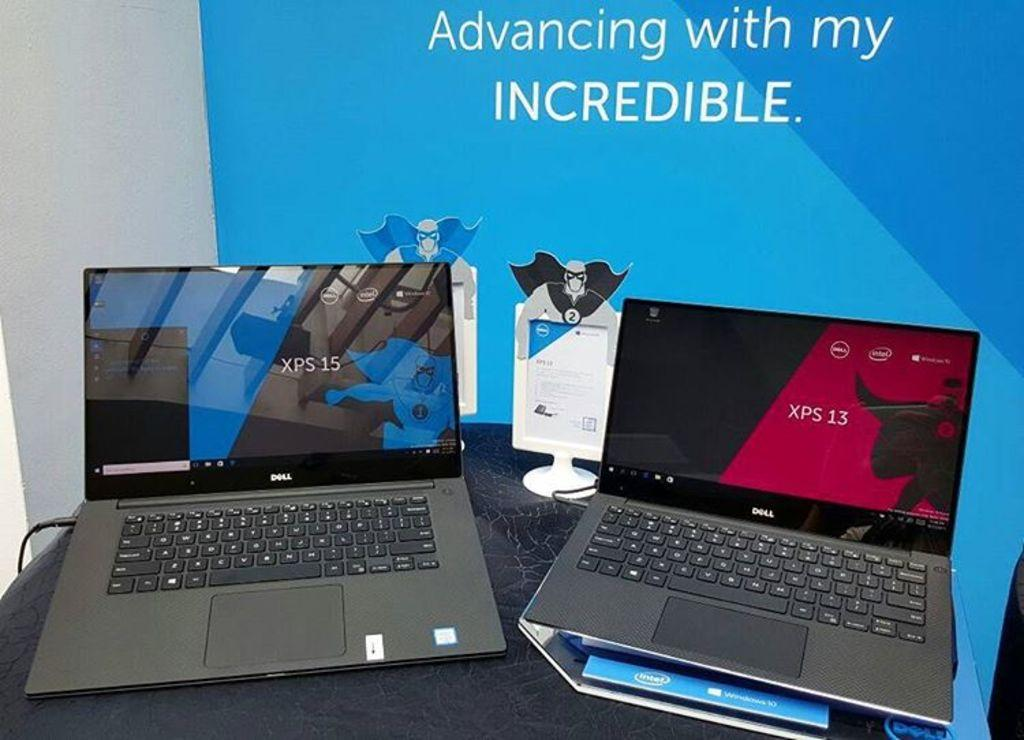<image>
Render a clear and concise summary of the photo. two Dell computers in front of a poster saying Incredible 